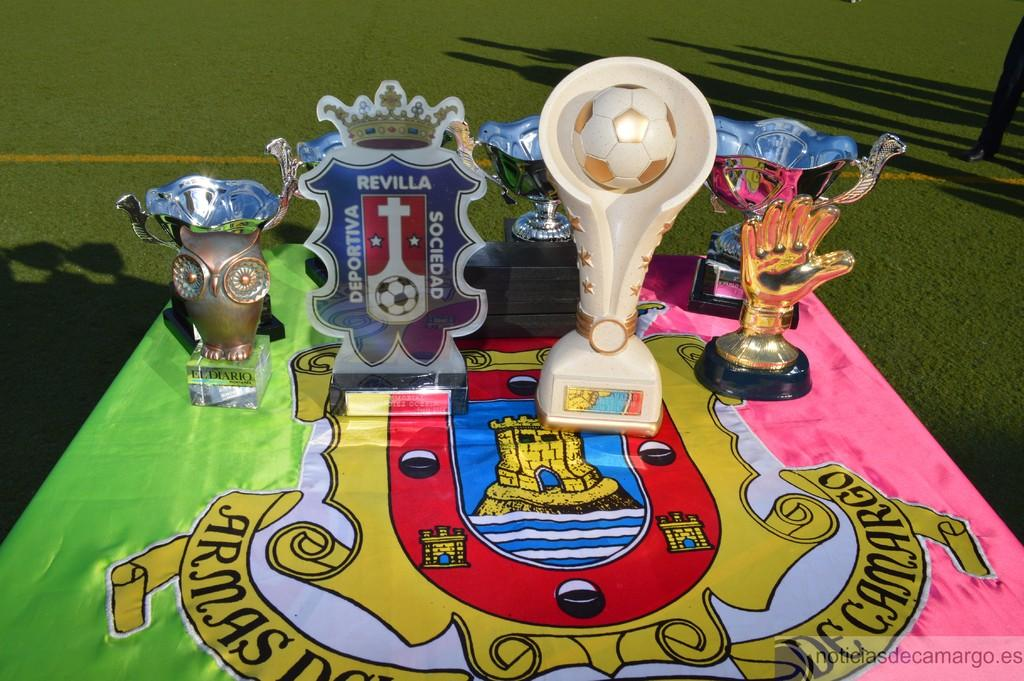<image>
Summarize the visual content of the image. Various awards on a table with a coat of arms on it and the word "Armas". 